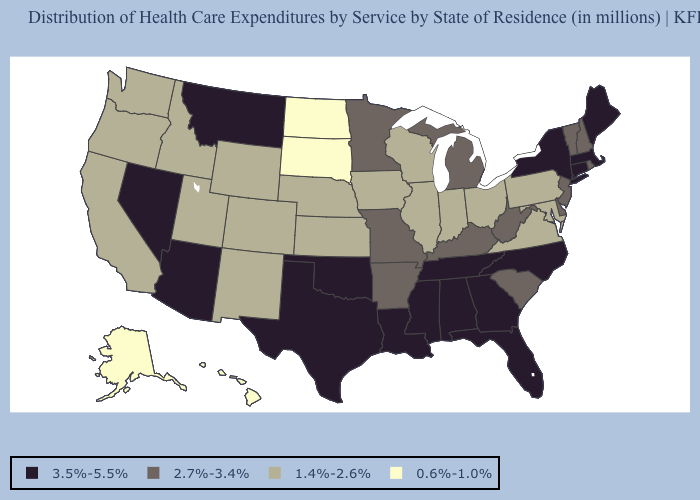Which states have the highest value in the USA?
Give a very brief answer. Alabama, Arizona, Connecticut, Florida, Georgia, Louisiana, Maine, Massachusetts, Mississippi, Montana, Nevada, New York, North Carolina, Oklahoma, Tennessee, Texas. Does Ohio have a higher value than Alaska?
Write a very short answer. Yes. What is the value of South Carolina?
Concise answer only. 2.7%-3.4%. Does South Dakota have the lowest value in the MidWest?
Be succinct. Yes. What is the value of North Dakota?
Concise answer only. 0.6%-1.0%. Name the states that have a value in the range 1.4%-2.6%?
Answer briefly. California, Colorado, Idaho, Illinois, Indiana, Iowa, Kansas, Maryland, Nebraska, New Mexico, Ohio, Oregon, Pennsylvania, Utah, Virginia, Washington, Wisconsin, Wyoming. What is the value of Georgia?
Answer briefly. 3.5%-5.5%. Does Alaska have the lowest value in the USA?
Be succinct. Yes. Does Michigan have the highest value in the MidWest?
Concise answer only. Yes. Does California have a higher value than Hawaii?
Write a very short answer. Yes. What is the value of Maine?
Concise answer only. 3.5%-5.5%. Does Iowa have the highest value in the MidWest?
Keep it brief. No. What is the value of Arizona?
Write a very short answer. 3.5%-5.5%. What is the value of Wyoming?
Keep it brief. 1.4%-2.6%. What is the value of Nevada?
Give a very brief answer. 3.5%-5.5%. 